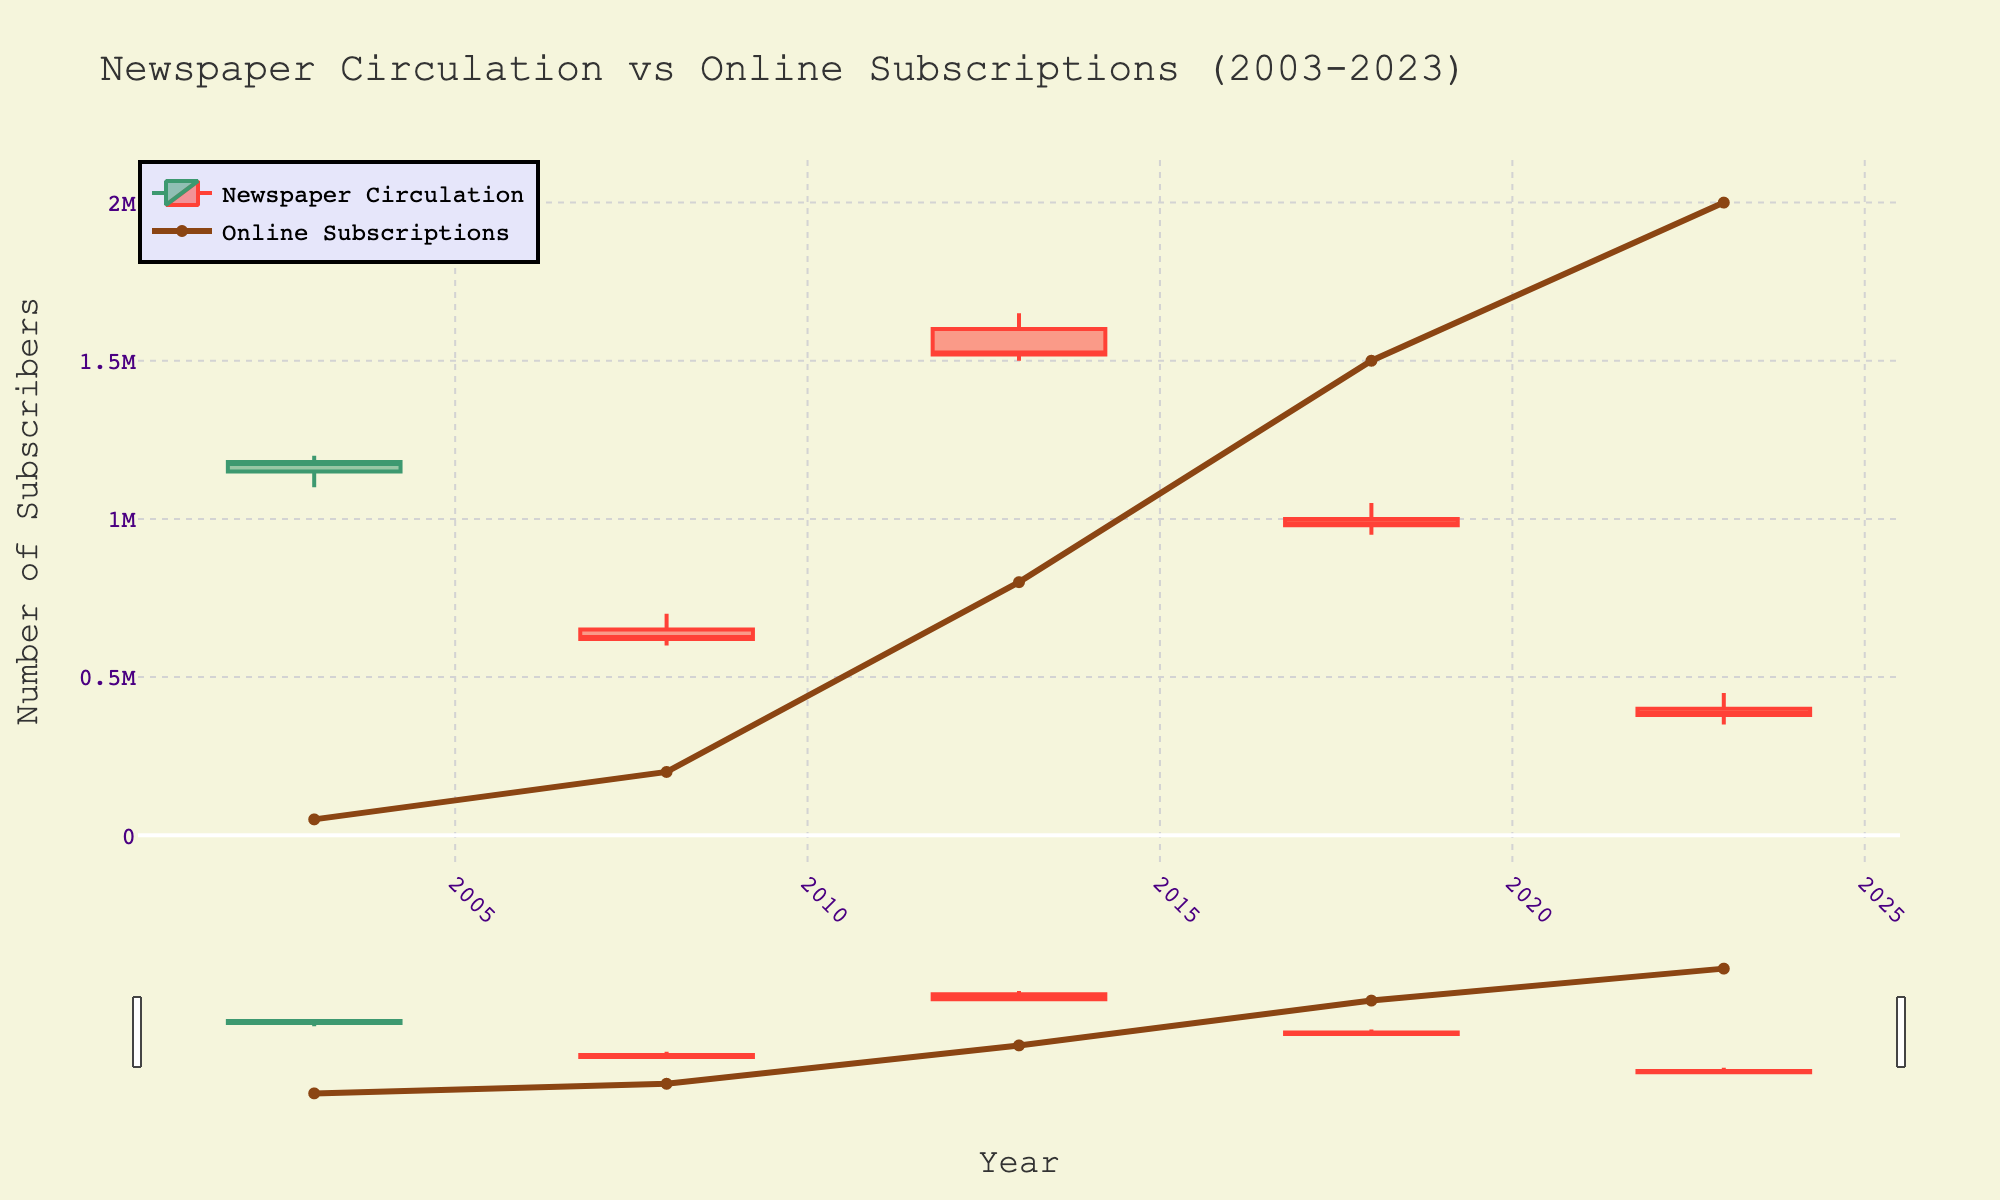what is the title of the chart? The title is located at the top center of the figure, and it provides an overview of what the graph is depicting.
Answer: Newspaper Circulation vs Online Subscriptions (2003-2023) how many years are covered in this chart? By observing the x-axis, which represents the years, each labeled tick indicates a specific year. There are five ticks, each representing a different year.
Answer: 5 what is the high value for 'USA Today' in 2013? The high value is visualized as the top of the wicks (vertical lines) in the candlestick for 'USA Today' in 2013.
Answer: 1,650,000 how do the online subscriptions for 'Wall Street Journal' in 2018 compare to 'New York Times' in 2003? Examine the line representing online subscriptions and compare the values for the respective years. 'Wall Street Journal' in 2018 has 1,500,000, which is much higher than 'New York Times' in 2003 with 50,000.
Answer: 1,500,000 vs 50,000 which newspaper had the lowest circulation number at its low point over the years, and what was that number? The low points in the candlesticks represent the lowest circulation numbers. Identify the lowest of these values by examining the bottom of the wicks across all years.
Answer: Los Angeles Times with 350,000 in 2023 what is the general trend in online subscriptions from 2003 to 2023? The orange line representing online subscriptions shows a clear upward trend over the years, increasing from 50,000 in 2003 to 2,000,000 in 2023.
Answer: Increasing which year had the highest range in newspaper circulation numbers for any specific newspaper and what are the open and close values for that year? The range is the difference between the high and low values indicated by the tops and bottoms of the candlesticks. 'USA Today' in 2013 has the largest range from 1,500,000 to 1,650,000.
Answer: 1,500,000 (Open), 1,520,000 (Close) how do the closing circulation numbers for 'Los Angeles Times' in 2023 compare to its own open value? The close value is represented by the end of the candlestick (smaller rectangles within the candlesticks), while the open value is the start of the candlestick. For 'Los Angeles Times' in 2023, the close is 380,000, which is lower than the open value of 400,000.
Answer: 380,000 is less than 400,000 which newspaper experienced the largest decline in circulation numbers from its high to low in a single year, and by how much? Calculate the difference between the high and low values for each candlestick to determine the largest decrease. 'USA Today' in 2013 had a decline from 1,650,000 to 1,500,000, which is a decline of 150,000.
Answer: 150,000 which newspaper showed the highest number of online subscriptions in the given data and in which year? The highest point on the line representing online subscriptions indicates the newspaper with the most online subscribers. 'Los Angeles Times' with 2,000,000 online subscribers in 2023.
Answer: Los Angeles Times, 2023 